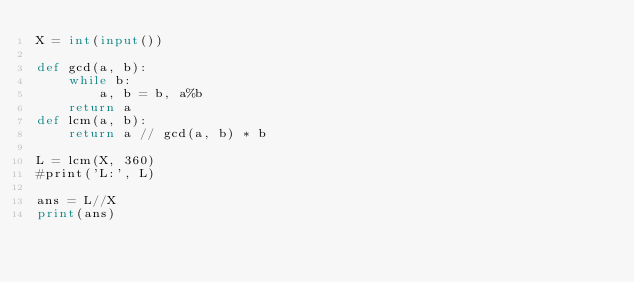Convert code to text. <code><loc_0><loc_0><loc_500><loc_500><_Python_>X = int(input())

def gcd(a, b):
    while b:
        a, b = b, a%b
    return a
def lcm(a, b):
    return a // gcd(a, b) * b

L = lcm(X, 360)
#print('L:', L)

ans = L//X
print(ans)
</code> 